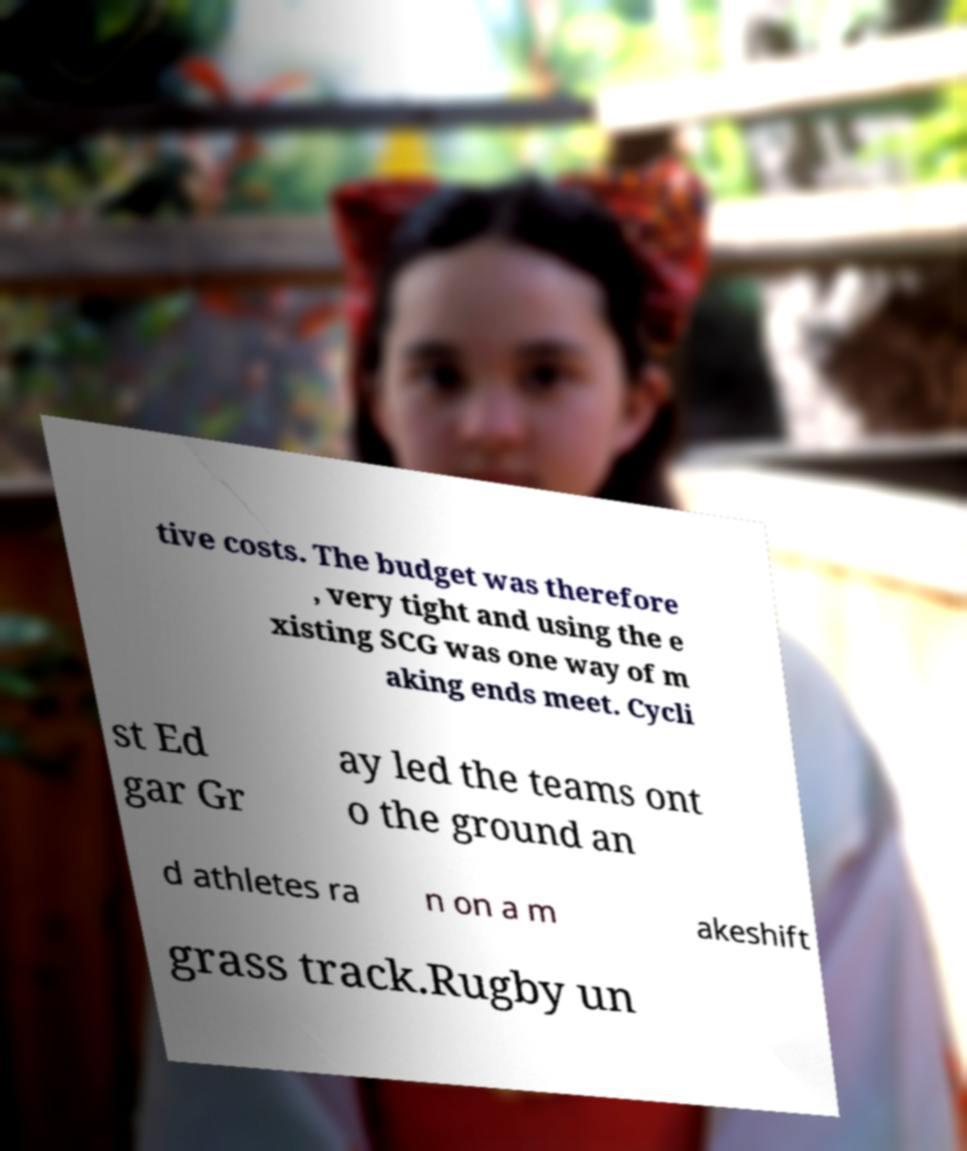For documentation purposes, I need the text within this image transcribed. Could you provide that? tive costs. The budget was therefore , very tight and using the e xisting SCG was one way of m aking ends meet. Cycli st Ed gar Gr ay led the teams ont o the ground an d athletes ra n on a m akeshift grass track.Rugby un 